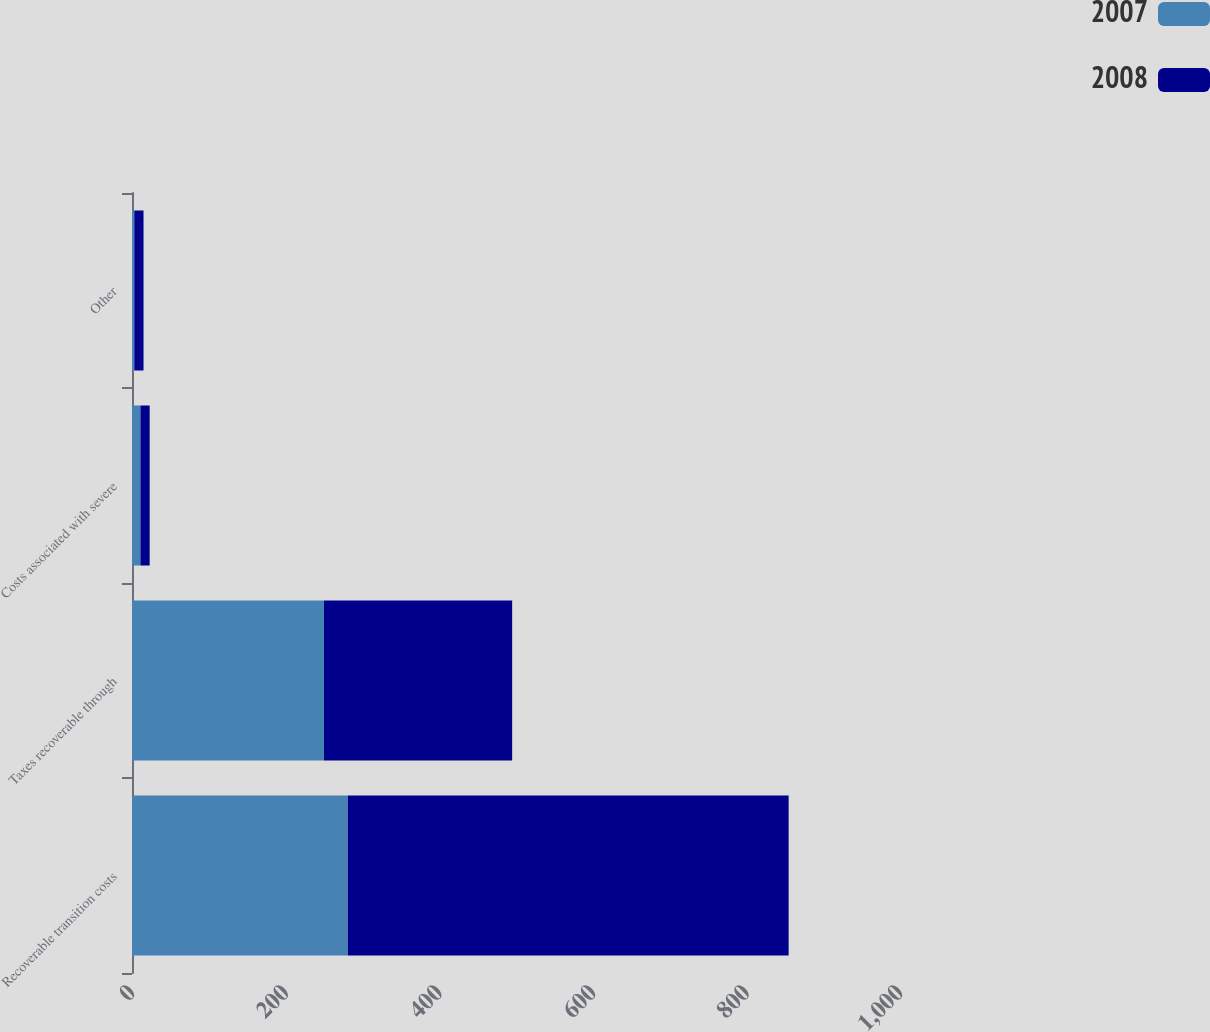<chart> <loc_0><loc_0><loc_500><loc_500><stacked_bar_chart><ecel><fcel>Recoverable transition costs<fcel>Taxes recoverable through<fcel>Costs associated with severe<fcel>Other<nl><fcel>2007<fcel>281<fcel>250<fcel>11<fcel>3<nl><fcel>2008<fcel>574<fcel>245<fcel>12<fcel>12<nl></chart> 